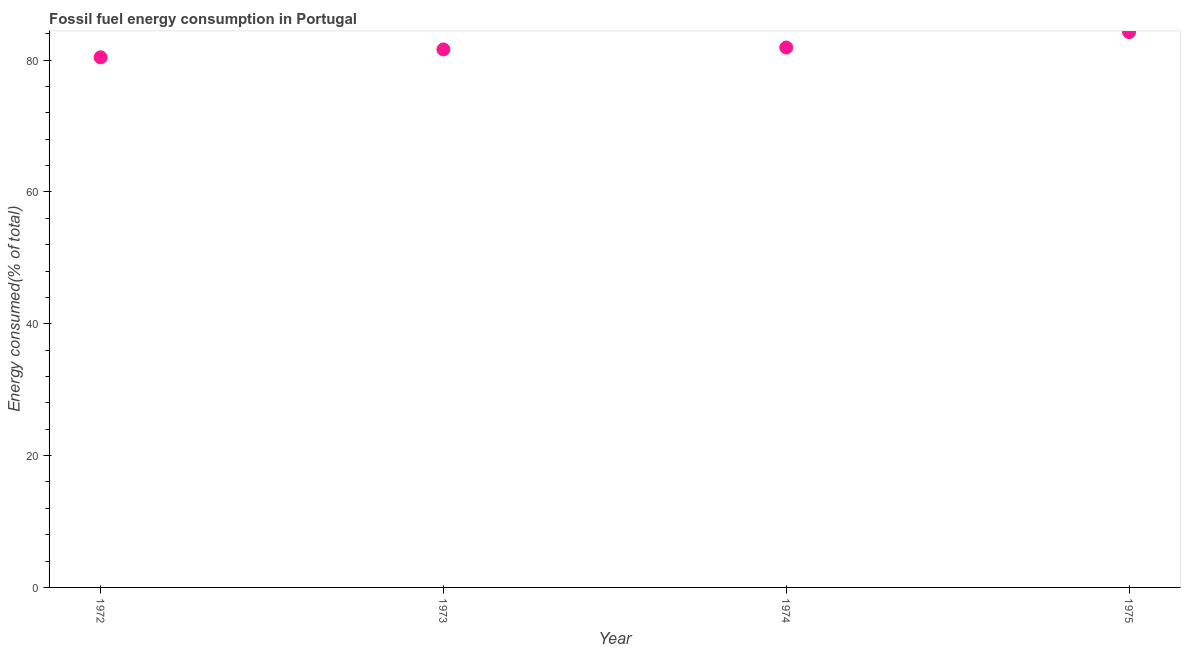What is the fossil fuel energy consumption in 1972?
Provide a succinct answer. 80.42. Across all years, what is the maximum fossil fuel energy consumption?
Provide a succinct answer. 84.25. Across all years, what is the minimum fossil fuel energy consumption?
Offer a very short reply. 80.42. In which year was the fossil fuel energy consumption maximum?
Offer a terse response. 1975. What is the sum of the fossil fuel energy consumption?
Provide a succinct answer. 328.19. What is the difference between the fossil fuel energy consumption in 1973 and 1975?
Your answer should be very brief. -2.63. What is the average fossil fuel energy consumption per year?
Keep it short and to the point. 82.05. What is the median fossil fuel energy consumption?
Keep it short and to the point. 81.76. What is the ratio of the fossil fuel energy consumption in 1974 to that in 1975?
Your response must be concise. 0.97. Is the fossil fuel energy consumption in 1974 less than that in 1975?
Your answer should be compact. Yes. What is the difference between the highest and the second highest fossil fuel energy consumption?
Keep it short and to the point. 2.34. What is the difference between the highest and the lowest fossil fuel energy consumption?
Provide a short and direct response. 3.82. In how many years, is the fossil fuel energy consumption greater than the average fossil fuel energy consumption taken over all years?
Make the answer very short. 1. Does the fossil fuel energy consumption monotonically increase over the years?
Keep it short and to the point. Yes. How many dotlines are there?
Ensure brevity in your answer.  1. What is the difference between two consecutive major ticks on the Y-axis?
Offer a terse response. 20. Are the values on the major ticks of Y-axis written in scientific E-notation?
Your response must be concise. No. Does the graph contain any zero values?
Your answer should be very brief. No. What is the title of the graph?
Keep it short and to the point. Fossil fuel energy consumption in Portugal. What is the label or title of the X-axis?
Offer a terse response. Year. What is the label or title of the Y-axis?
Offer a terse response. Energy consumed(% of total). What is the Energy consumed(% of total) in 1972?
Keep it short and to the point. 80.42. What is the Energy consumed(% of total) in 1973?
Provide a succinct answer. 81.62. What is the Energy consumed(% of total) in 1974?
Your response must be concise. 81.9. What is the Energy consumed(% of total) in 1975?
Provide a succinct answer. 84.25. What is the difference between the Energy consumed(% of total) in 1972 and 1973?
Ensure brevity in your answer.  -1.19. What is the difference between the Energy consumed(% of total) in 1972 and 1974?
Ensure brevity in your answer.  -1.48. What is the difference between the Energy consumed(% of total) in 1972 and 1975?
Keep it short and to the point. -3.82. What is the difference between the Energy consumed(% of total) in 1973 and 1974?
Provide a succinct answer. -0.29. What is the difference between the Energy consumed(% of total) in 1973 and 1975?
Provide a short and direct response. -2.63. What is the difference between the Energy consumed(% of total) in 1974 and 1975?
Make the answer very short. -2.34. What is the ratio of the Energy consumed(% of total) in 1972 to that in 1973?
Give a very brief answer. 0.98. What is the ratio of the Energy consumed(% of total) in 1972 to that in 1974?
Offer a very short reply. 0.98. What is the ratio of the Energy consumed(% of total) in 1972 to that in 1975?
Give a very brief answer. 0.95. What is the ratio of the Energy consumed(% of total) in 1973 to that in 1974?
Provide a short and direct response. 1. 